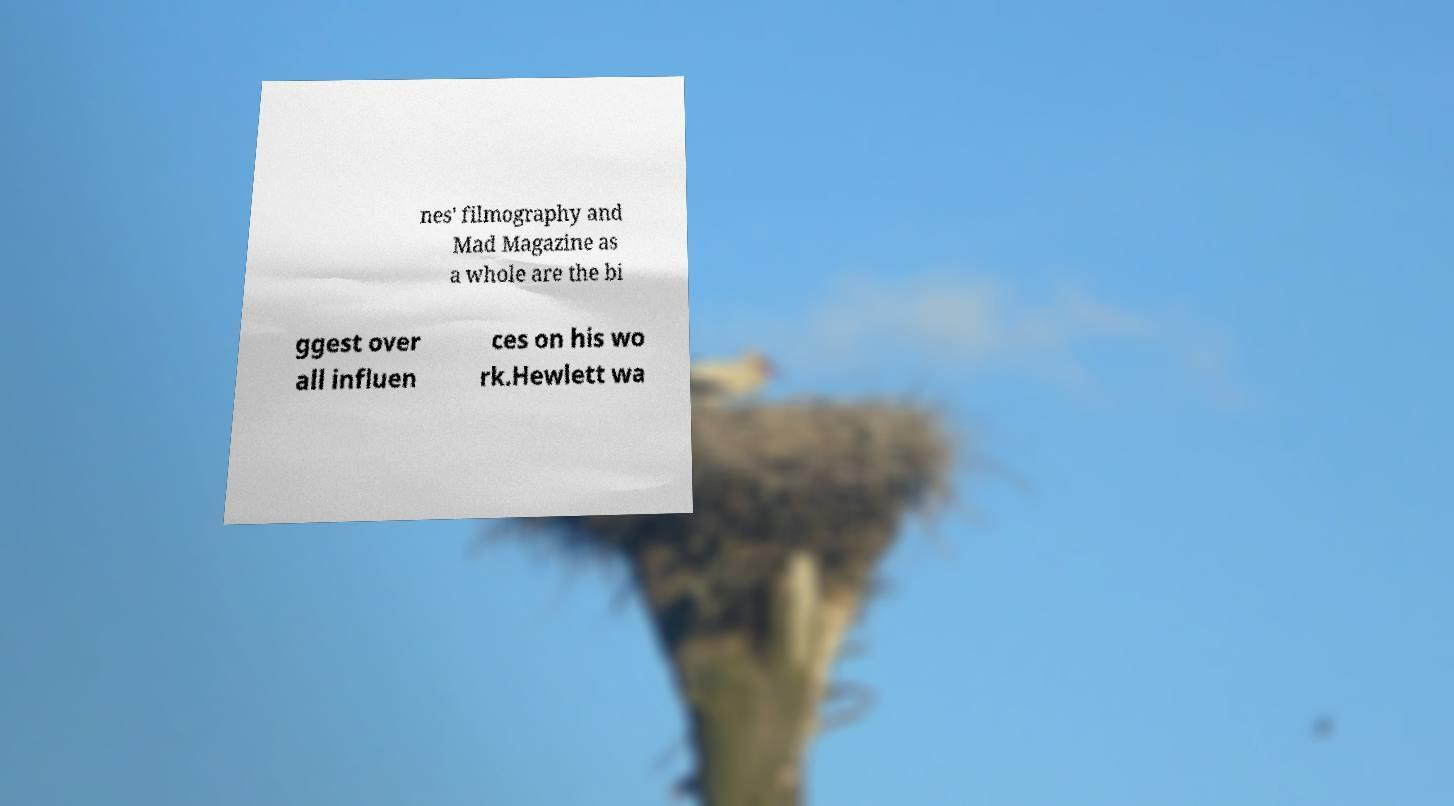Could you extract and type out the text from this image? nes' filmography and Mad Magazine as a whole are the bi ggest over all influen ces on his wo rk.Hewlett wa 